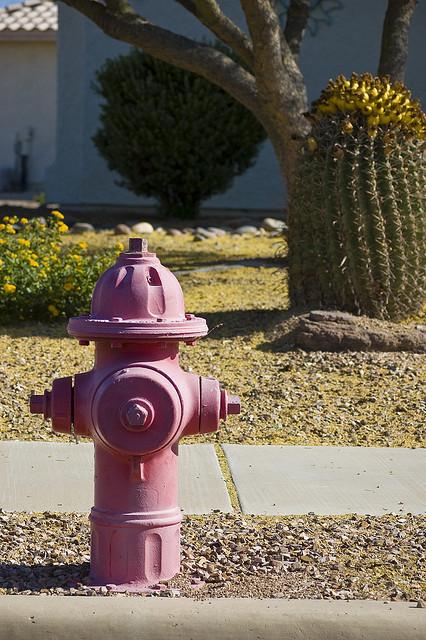Does the plant on the right require much water?
Write a very short answer. No. Are all the flowers in the photo yellow?
Be succinct. Yes. Do you see water coming out?
Write a very short answer. No. Was the paint applied neatly?
Answer briefly. Yes. 